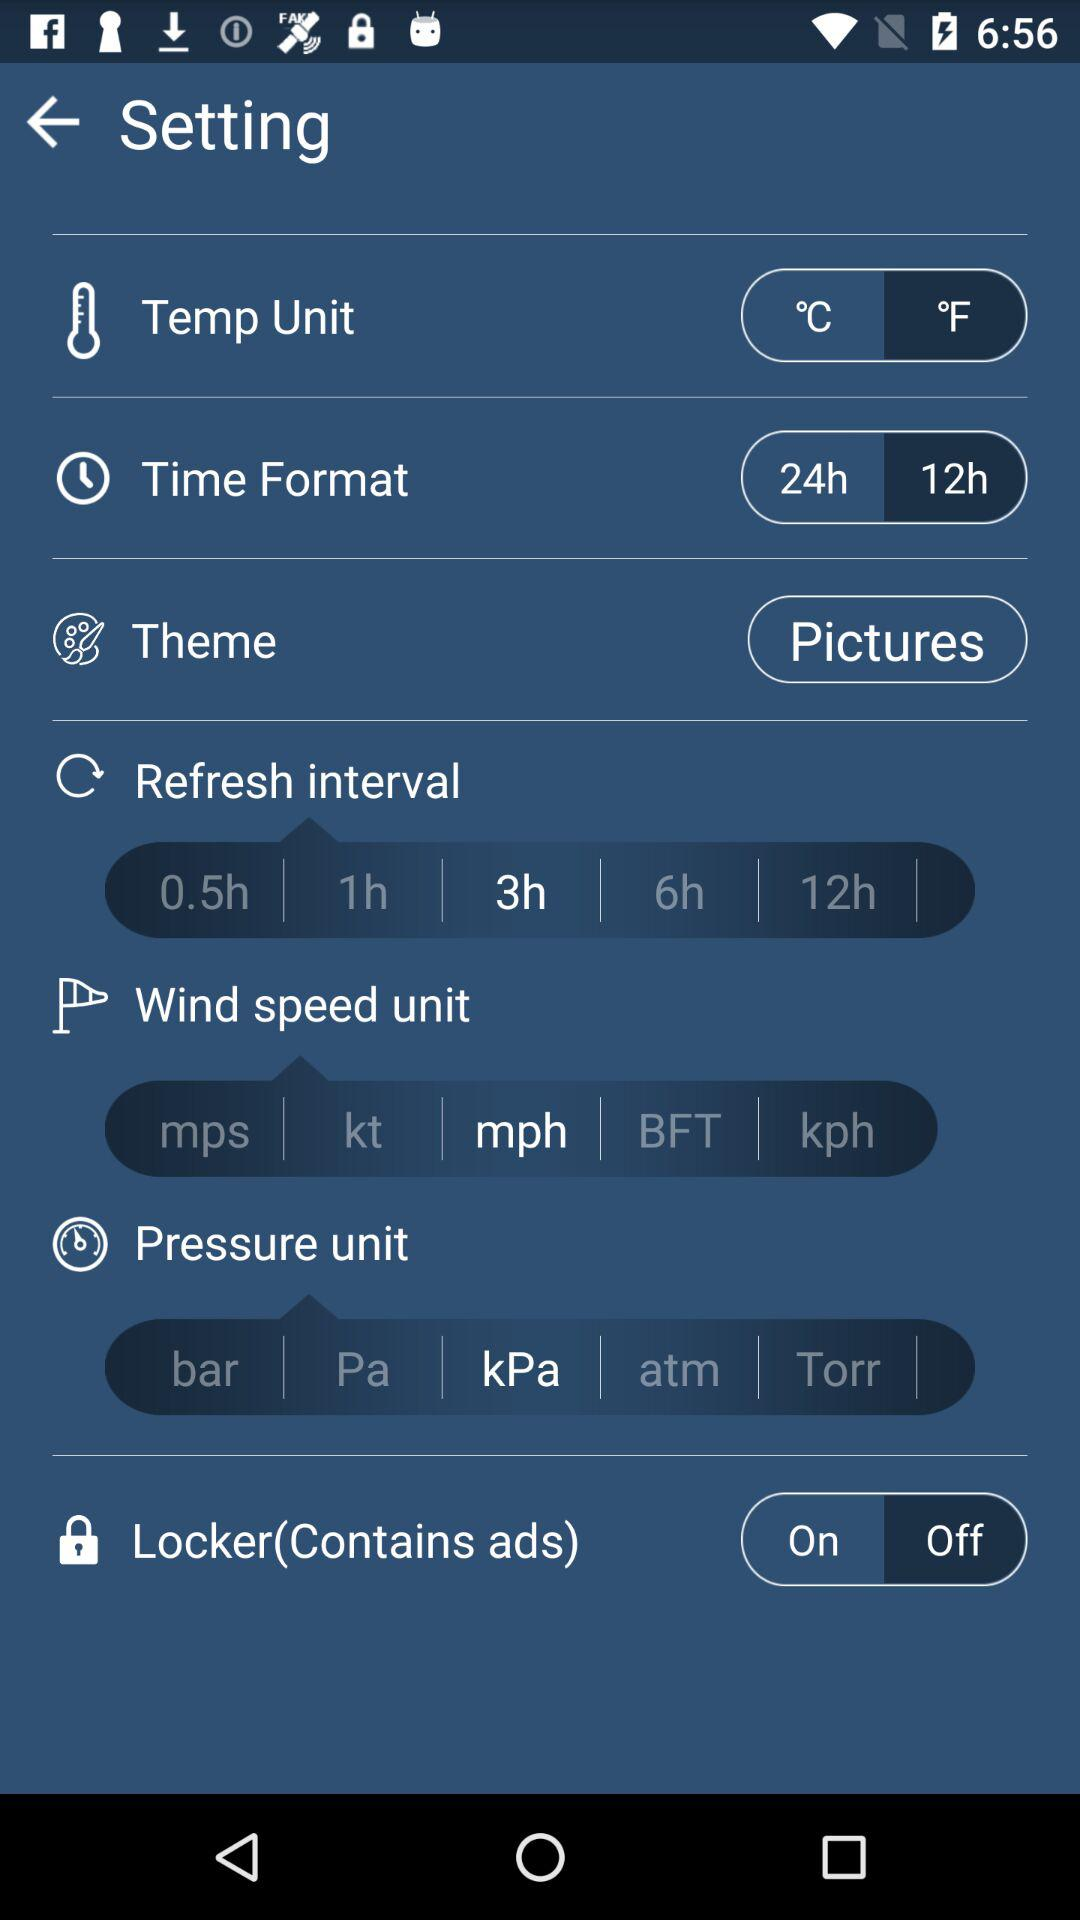Which pressure unit has been selected? The selected pressure unit is kPa. 